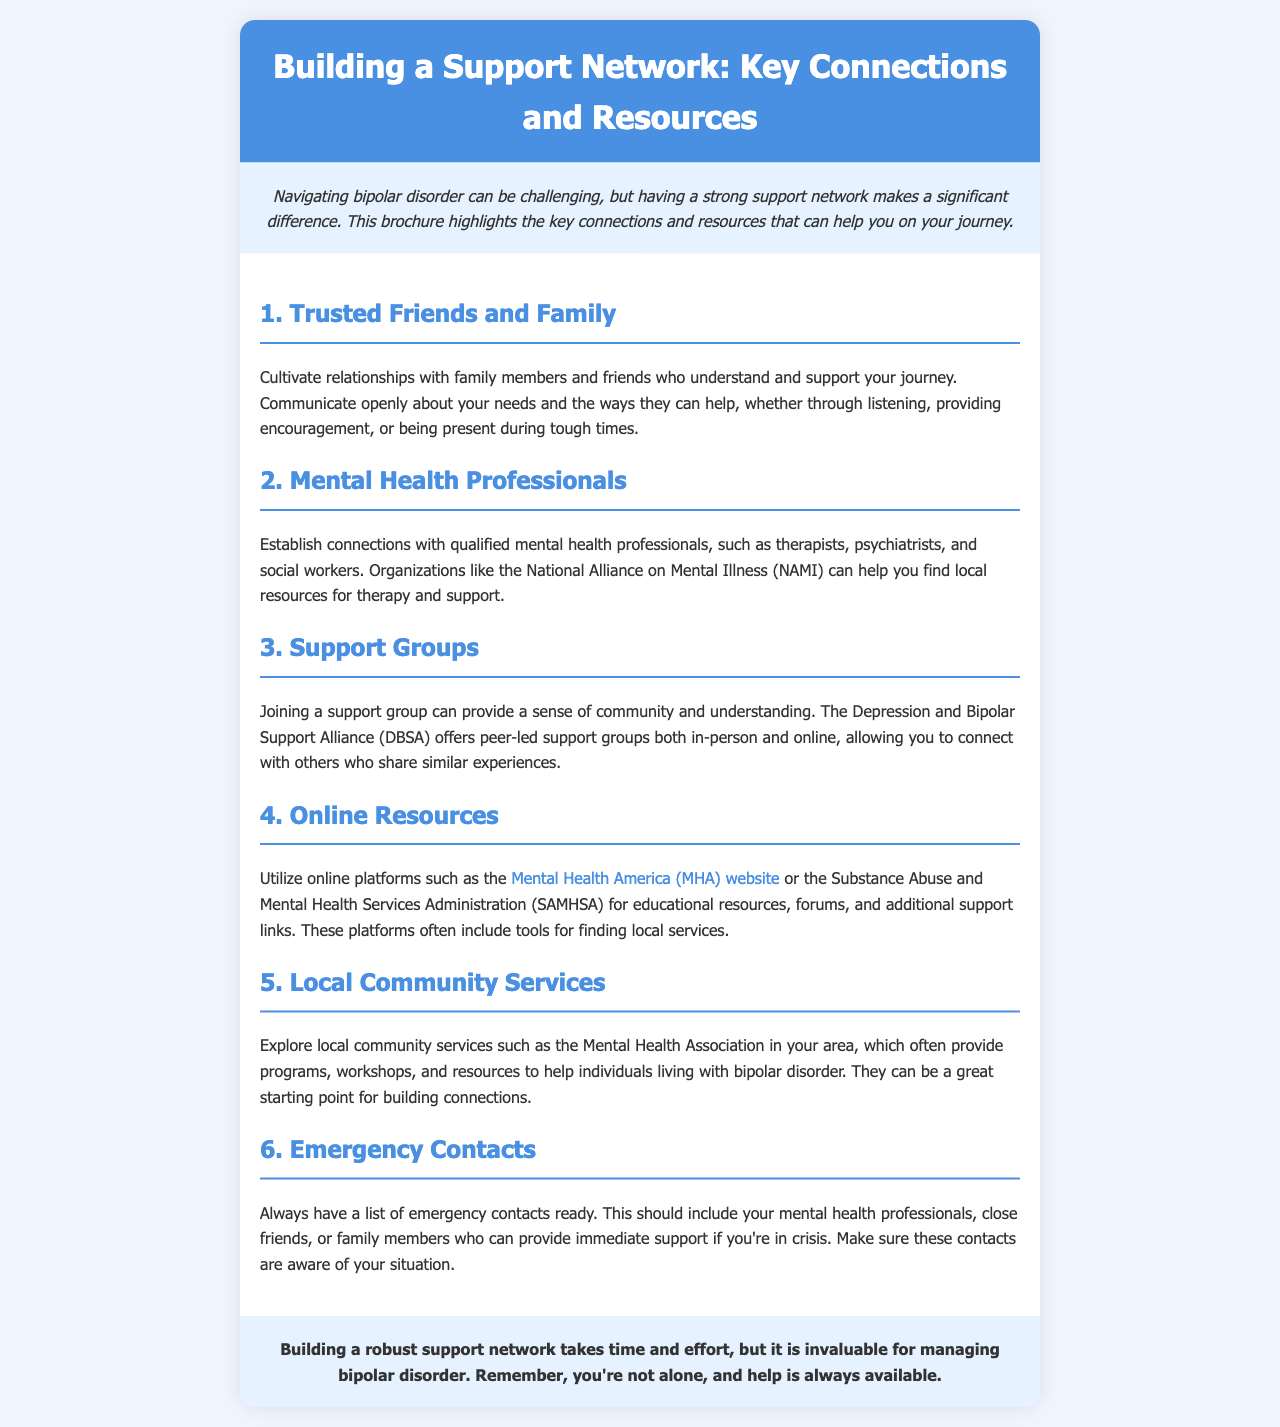What is the purpose of this brochure? The brochure aims to highlight key connections and resources that can help individuals navigate bipolar disorder.
Answer: To highlight key connections and resources How many key sections are in the brochure? There are six key sections listed in the brochure that provide information on building a support network.
Answer: Six What organization helps you find local resources for therapy and support? The brochure mentions the National Alliance on Mental Illness (NAMI) as an organization to find local resources.
Answer: NAMI What kind of support does the Depression and Bipolar Support Alliance (DBSA) provide? DBSA offers peer-led support groups both in-person and online, allowing connections with others.
Answer: Peer-led support groups What should be included in your list of emergency contacts? The list of emergency contacts should include mental health professionals, close friends, or family members who can provide immediate support.
Answer: Mental health professionals, close friends, family members What role do local community services play according to the brochure? Local community services provide programs, workshops, and resources to help individuals living with bipolar disorder.
Answer: Programs, workshops, resources 